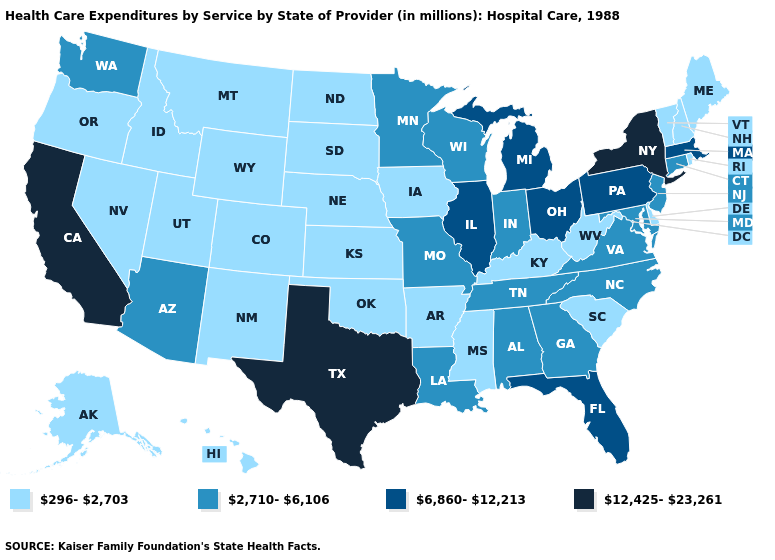Name the states that have a value in the range 12,425-23,261?
Keep it brief. California, New York, Texas. Does the first symbol in the legend represent the smallest category?
Give a very brief answer. Yes. What is the value of Tennessee?
Give a very brief answer. 2,710-6,106. Does the first symbol in the legend represent the smallest category?
Keep it brief. Yes. Is the legend a continuous bar?
Quick response, please. No. Name the states that have a value in the range 296-2,703?
Write a very short answer. Alaska, Arkansas, Colorado, Delaware, Hawaii, Idaho, Iowa, Kansas, Kentucky, Maine, Mississippi, Montana, Nebraska, Nevada, New Hampshire, New Mexico, North Dakota, Oklahoma, Oregon, Rhode Island, South Carolina, South Dakota, Utah, Vermont, West Virginia, Wyoming. Name the states that have a value in the range 296-2,703?
Concise answer only. Alaska, Arkansas, Colorado, Delaware, Hawaii, Idaho, Iowa, Kansas, Kentucky, Maine, Mississippi, Montana, Nebraska, Nevada, New Hampshire, New Mexico, North Dakota, Oklahoma, Oregon, Rhode Island, South Carolina, South Dakota, Utah, Vermont, West Virginia, Wyoming. Does Ohio have the highest value in the MidWest?
Be succinct. Yes. What is the value of Massachusetts?
Be succinct. 6,860-12,213. Is the legend a continuous bar?
Keep it brief. No. Does Mississippi have the same value as Nebraska?
Short answer required. Yes. Among the states that border West Virginia , does Kentucky have the lowest value?
Give a very brief answer. Yes. Among the states that border Oregon , does Washington have the highest value?
Keep it brief. No. What is the highest value in the West ?
Quick response, please. 12,425-23,261. 